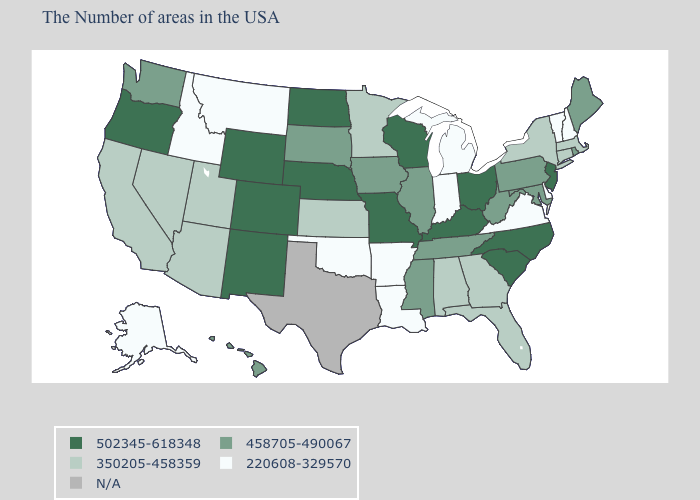What is the value of New York?
Be succinct. 350205-458359. What is the value of Utah?
Write a very short answer. 350205-458359. Which states have the lowest value in the USA?
Be succinct. New Hampshire, Vermont, Delaware, Virginia, Michigan, Indiana, Louisiana, Arkansas, Oklahoma, Montana, Idaho, Alaska. Name the states that have a value in the range 502345-618348?
Write a very short answer. New Jersey, North Carolina, South Carolina, Ohio, Kentucky, Wisconsin, Missouri, Nebraska, North Dakota, Wyoming, Colorado, New Mexico, Oregon. Which states hav the highest value in the West?
Answer briefly. Wyoming, Colorado, New Mexico, Oregon. Does Montana have the lowest value in the West?
Give a very brief answer. Yes. What is the value of Washington?
Write a very short answer. 458705-490067. What is the value of North Carolina?
Short answer required. 502345-618348. Among the states that border Pennsylvania , which have the lowest value?
Write a very short answer. Delaware. Does the map have missing data?
Be succinct. Yes. What is the lowest value in states that border Iowa?
Quick response, please. 350205-458359. Which states have the highest value in the USA?
Concise answer only. New Jersey, North Carolina, South Carolina, Ohio, Kentucky, Wisconsin, Missouri, Nebraska, North Dakota, Wyoming, Colorado, New Mexico, Oregon. 